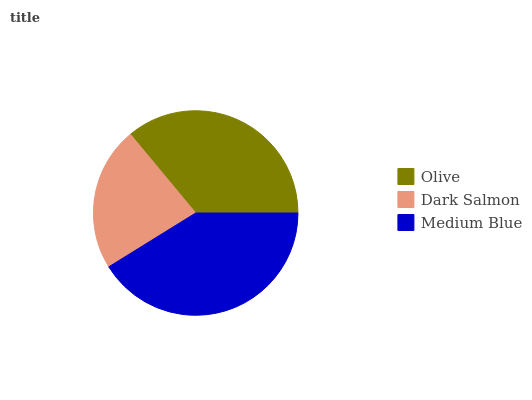Is Dark Salmon the minimum?
Answer yes or no. Yes. Is Medium Blue the maximum?
Answer yes or no. Yes. Is Medium Blue the minimum?
Answer yes or no. No. Is Dark Salmon the maximum?
Answer yes or no. No. Is Medium Blue greater than Dark Salmon?
Answer yes or no. Yes. Is Dark Salmon less than Medium Blue?
Answer yes or no. Yes. Is Dark Salmon greater than Medium Blue?
Answer yes or no. No. Is Medium Blue less than Dark Salmon?
Answer yes or no. No. Is Olive the high median?
Answer yes or no. Yes. Is Olive the low median?
Answer yes or no. Yes. Is Dark Salmon the high median?
Answer yes or no. No. Is Dark Salmon the low median?
Answer yes or no. No. 